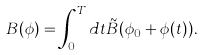<formula> <loc_0><loc_0><loc_500><loc_500>B ( \phi ) = \int ^ { T } _ { 0 } d t \tilde { B } ( \phi _ { 0 } + \phi ( t ) ) .</formula> 